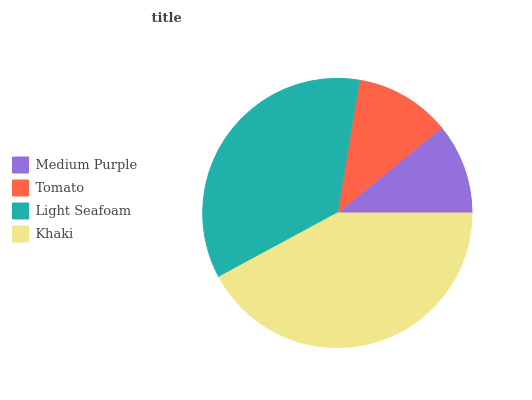Is Medium Purple the minimum?
Answer yes or no. Yes. Is Khaki the maximum?
Answer yes or no. Yes. Is Tomato the minimum?
Answer yes or no. No. Is Tomato the maximum?
Answer yes or no. No. Is Tomato greater than Medium Purple?
Answer yes or no. Yes. Is Medium Purple less than Tomato?
Answer yes or no. Yes. Is Medium Purple greater than Tomato?
Answer yes or no. No. Is Tomato less than Medium Purple?
Answer yes or no. No. Is Light Seafoam the high median?
Answer yes or no. Yes. Is Tomato the low median?
Answer yes or no. Yes. Is Medium Purple the high median?
Answer yes or no. No. Is Medium Purple the low median?
Answer yes or no. No. 